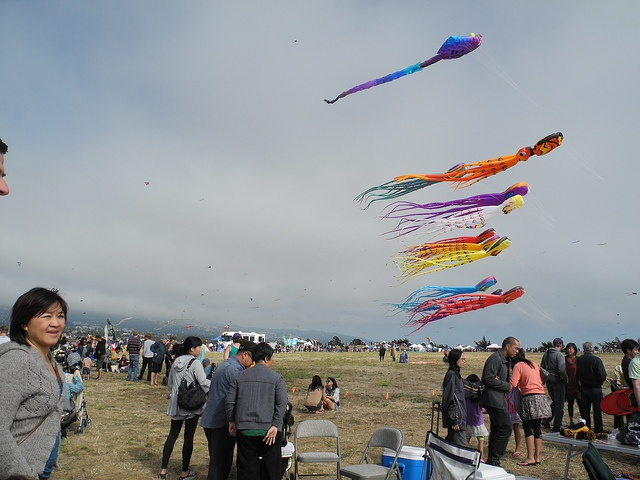Describe the objects in this image and their specific colors. I can see people in gray and black tones, kite in gray, darkgray, lightgray, and olive tones, people in gray and black tones, people in gray, black, and darkgray tones, and kite in gray, red, brown, and darkgray tones in this image. 